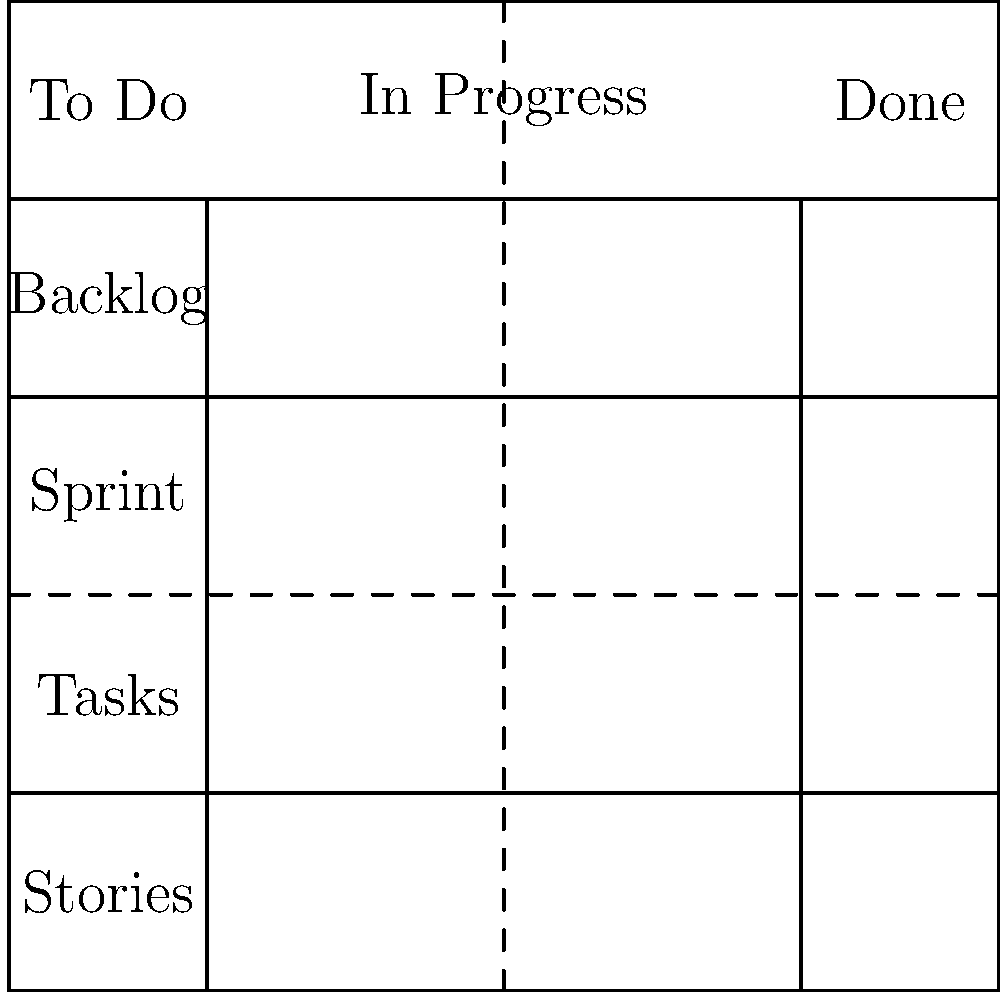In designing an ideal Scrum board layout for your Agile development team, you've created a rectangular board with parallel columns and perpendicular rows. The board is divided into three main sections: "To Do," "In Progress," and "Done." If the total width of the board is 10 units and the "In Progress" section is 3 units wide, what is the combined width of the "To Do" and "Done" sections? To solve this problem, let's break it down step-by-step:

1. Understand the given information:
   - The total width of the board is 10 units.
   - The "In Progress" section is 3 units wide.

2. Set up an equation:
   Let $x$ be the combined width of "To Do" and "Done" sections.
   Total width = Width of "To Do" and "Done" + Width of "In Progress"
   $$10 = x + 3$$

3. Solve the equation:
   $$x = 10 - 3$$
   $$x = 7$$

4. Interpret the result:
   The combined width of the "To Do" and "Done" sections is 7 units.

This layout ensures that the Scrum board efficiently displays all necessary information while maintaining proper proportions for each section, allowing your Agile team to effectively track progress throughout the sprint.
Answer: 7 units 